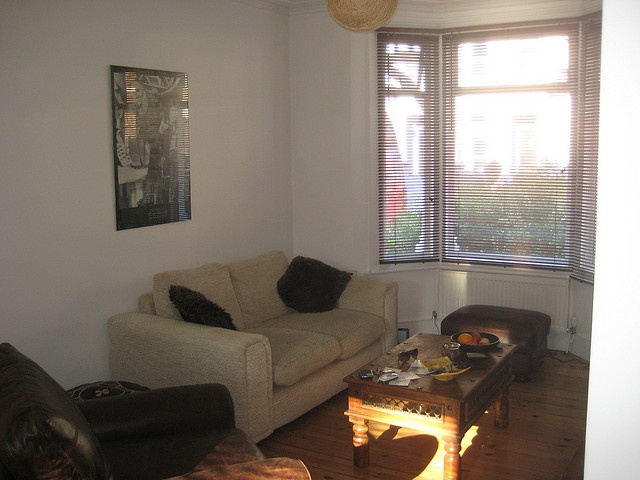Describe the objects in this image and their specific colors. I can see couch in gray and black tones, chair in gray, black, and maroon tones, bowl in gray, olive, maroon, and black tones, bowl in gray, black, maroon, and brown tones, and cell phone in gray, darkgray, and black tones in this image. 